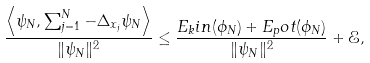Convert formula to latex. <formula><loc_0><loc_0><loc_500><loc_500>\frac { \left \langle \psi _ { N } , \sum _ { j = 1 } ^ { N } - \Delta _ { x _ { j } } \psi _ { N } \right \rangle } { \| \psi _ { N } \| ^ { 2 } } \leq \frac { E _ { k } i n ( \phi _ { N } ) + E _ { p } o t ( \phi _ { N } ) } { \| \psi _ { N } \| ^ { 2 } } + \mathcal { E } ,</formula> 